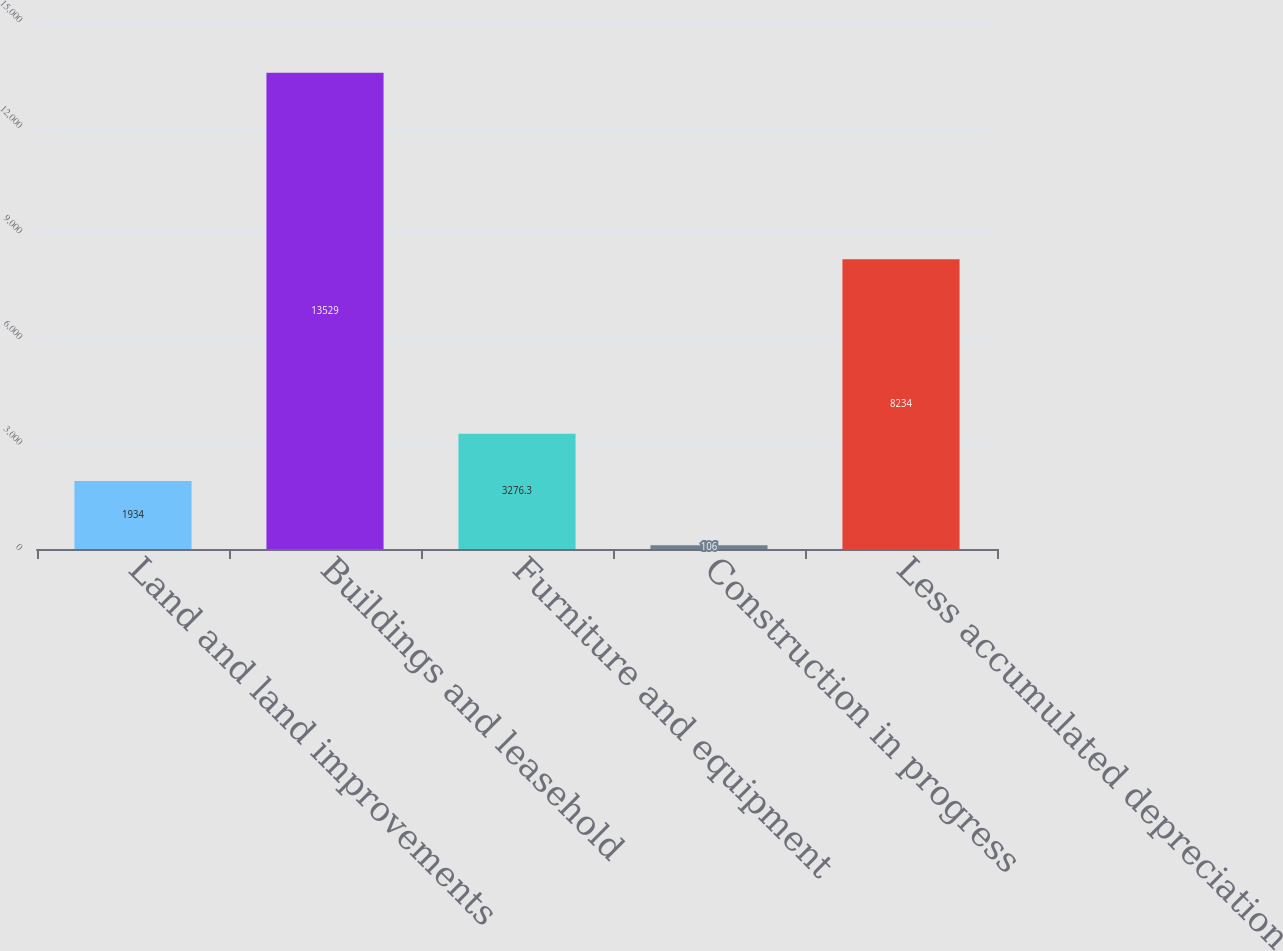Convert chart. <chart><loc_0><loc_0><loc_500><loc_500><bar_chart><fcel>Land and land improvements<fcel>Buildings and leasehold<fcel>Furniture and equipment<fcel>Construction in progress<fcel>Less accumulated depreciation<nl><fcel>1934<fcel>13529<fcel>3276.3<fcel>106<fcel>8234<nl></chart> 